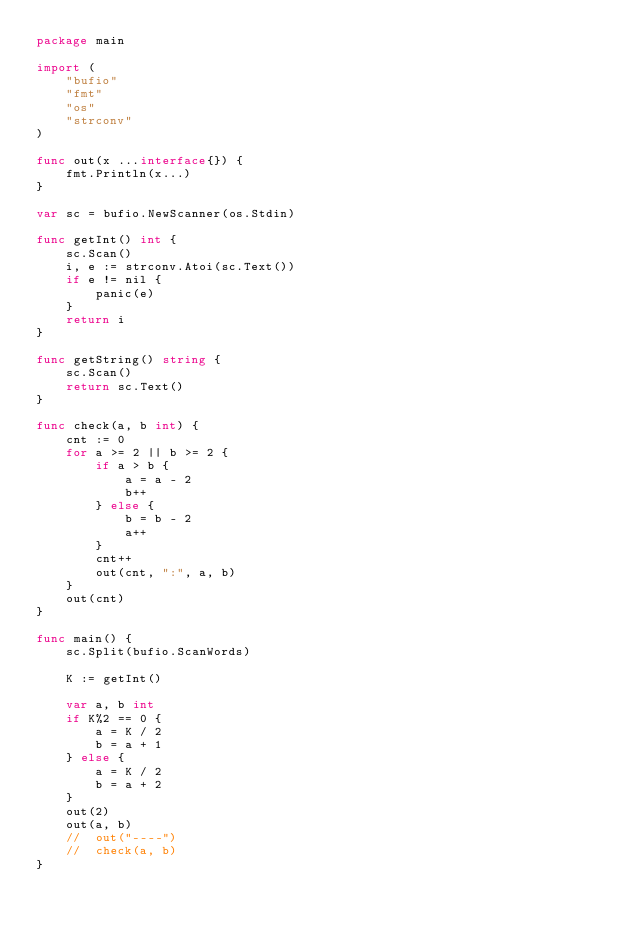Convert code to text. <code><loc_0><loc_0><loc_500><loc_500><_Go_>package main

import (
	"bufio"
	"fmt"
	"os"
	"strconv"
)

func out(x ...interface{}) {
	fmt.Println(x...)
}

var sc = bufio.NewScanner(os.Stdin)

func getInt() int {
	sc.Scan()
	i, e := strconv.Atoi(sc.Text())
	if e != nil {
		panic(e)
	}
	return i
}

func getString() string {
	sc.Scan()
	return sc.Text()
}

func check(a, b int) {
	cnt := 0
	for a >= 2 || b >= 2 {
		if a > b {
			a = a - 2
			b++
		} else {
			b = b - 2
			a++
		}
		cnt++
		out(cnt, ":", a, b)
	}
	out(cnt)
}

func main() {
	sc.Split(bufio.ScanWords)

	K := getInt()

	var a, b int
	if K%2 == 0 {
		a = K / 2
		b = a + 1
	} else {
		a = K / 2
		b = a + 2
	}
	out(2)
	out(a, b)
	//	out("----")
	//	check(a, b)
}
</code> 